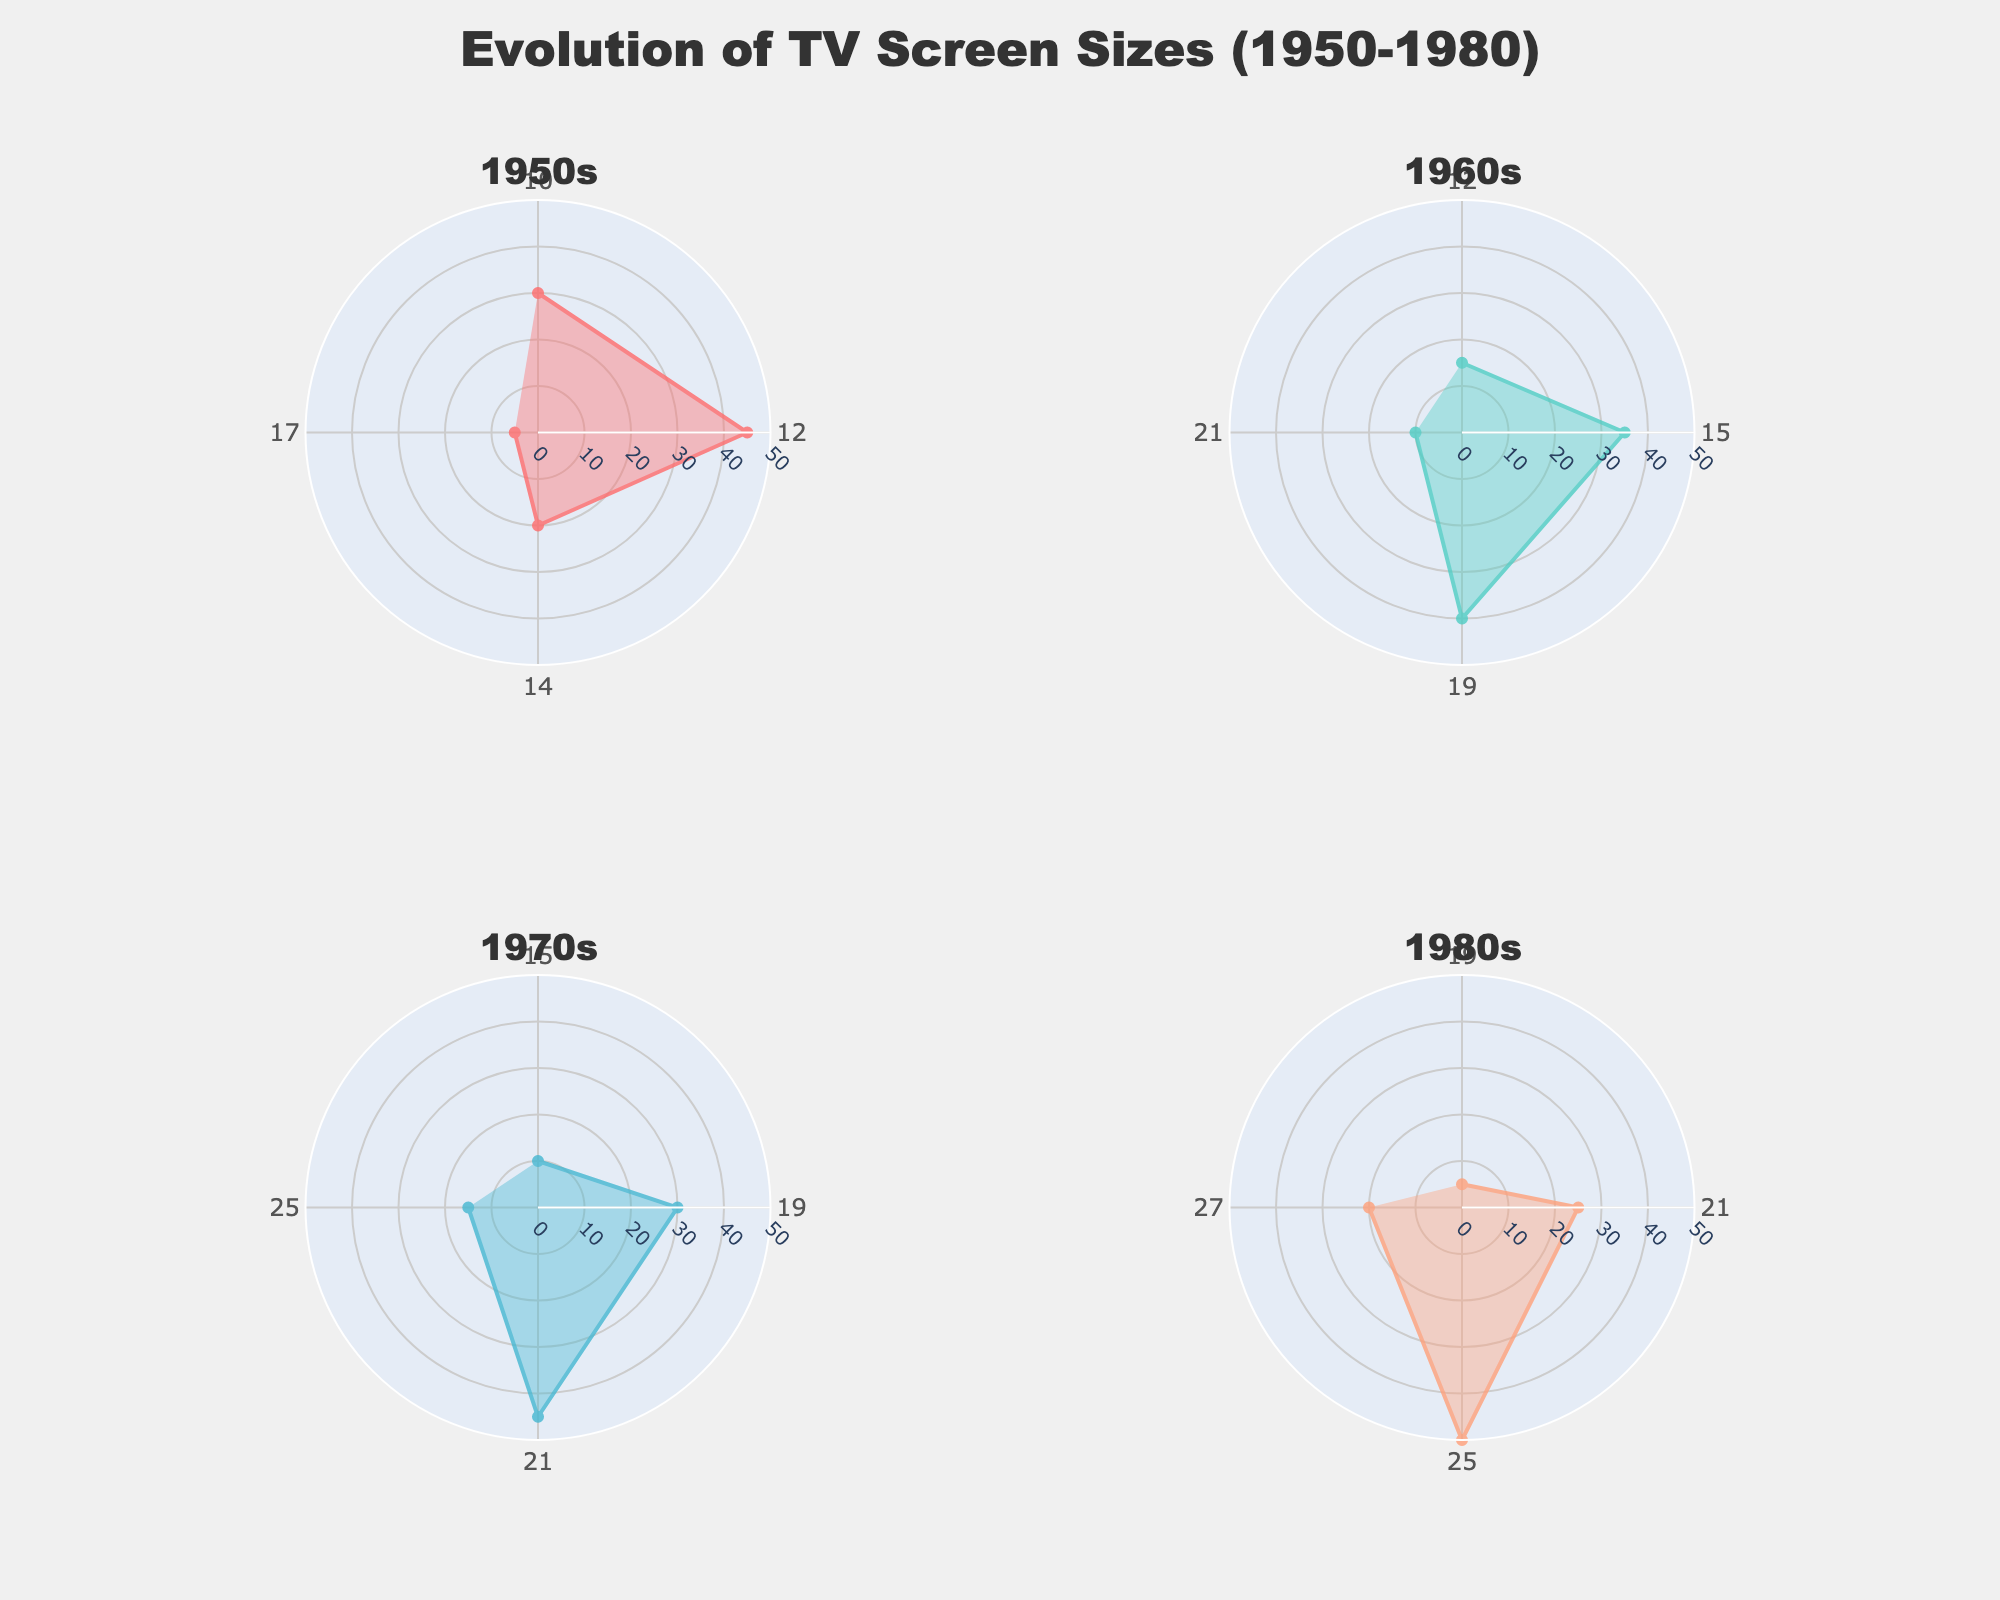What is the title of the chart? The title is typically placed at the top of the chart and describes the main content or purpose. In this case, it is clearly indicated.
Answer: Evolution of TV Screen Sizes (1950-1980) What screen size had the highest market share in the 1950s? Look for the largest segment in the 1950s polar chart subplot and identify the screen size in the legend.
Answer: 12 inches In the 1970s, which screen size had the smallest market share? Find the smallest segment in the 1970s polar chart subplot and cross-reference it with the screen size in the legend.
Answer: 15 inches Compare the market shares of 25-inch TVs in the 1970s and the 1980s. Which decade had a higher market share for this screen size? Look at the sizes and positions of the segments for the 25-inch TVs in both the 1970s and 1980s subplots and identify which one is larger.
Answer: 1980s What is the average market share of the screen sizes in the 1960s? To calculate the average, sum the market shares of all screen sizes in the 1960s and divide by the number of sizes. The shares are 15%, 35%, 40%, and 10%. (15+35+40+10)/4 = 25%
Answer: 25% Which decade shows the highest diversity of screen sizes? Diversity can be judged by the number of different screen sizes in each decade’s subplot.
Answer: 1950s How does the screen size distribution trend from the 1950s to the 1980s? Review the subplots from 1950s to 1980s to observe the changes in screen sizes and their market shares over time, noting any trends.
Answer: Screen sizes generally become larger with increased market shares for those larger sizes over time For the 21-inch screen, which decade shows the largest drop in market share compared to previous decades? Compare the market shares of the 21-inch screens across all subplots and identify the largest drop between any two consecutive decades. In the 1960s it's 10%, in the 1970s it's 45%, and in the 1980s it's 25%.
Answer: 1980s What is the relative change in market share for the 27-inch screen between the 1980s and 1990s? Calculate the percentage change in market share for the 27-inch screen by subtracting the 1980s market share from the 1990s, then divide by the 1980s share, and multiply by 100. ((35-20)/20)*100 = 75%
Answer: 75% 